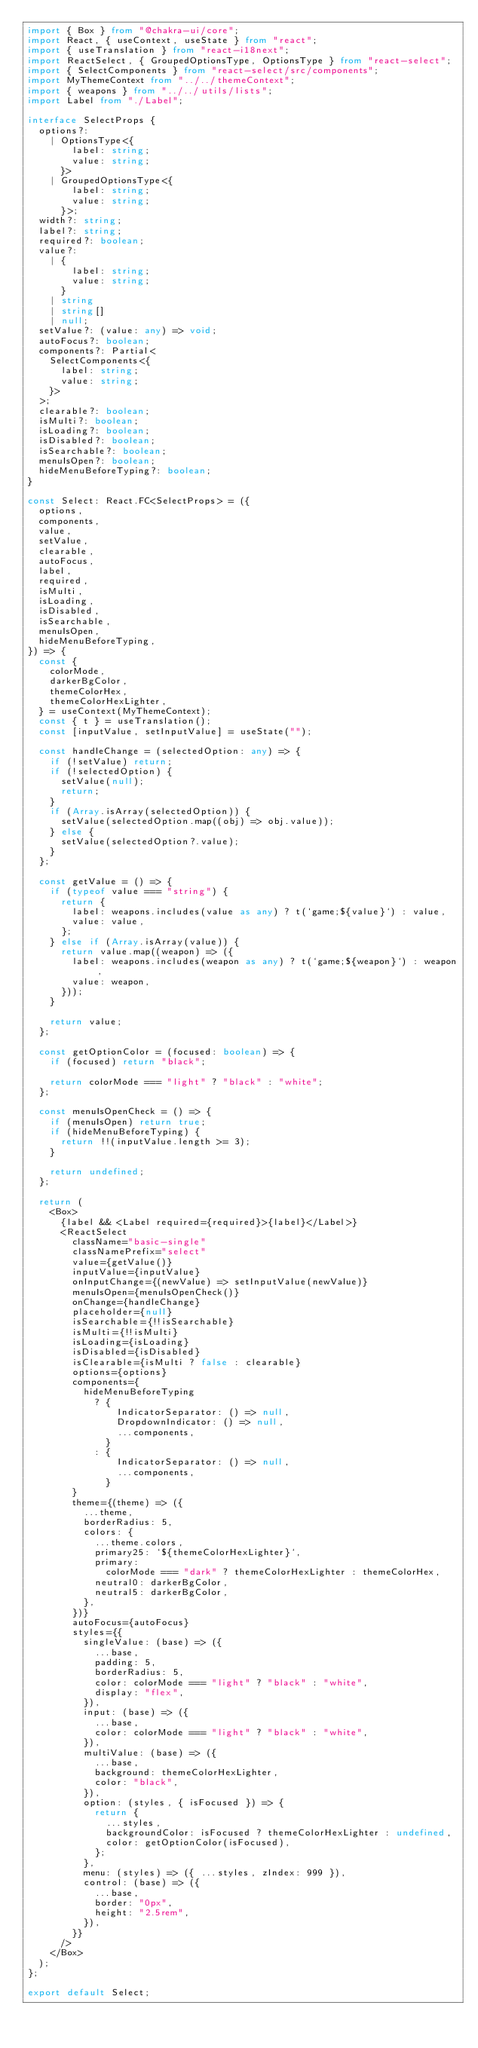<code> <loc_0><loc_0><loc_500><loc_500><_TypeScript_>import { Box } from "@chakra-ui/core";
import React, { useContext, useState } from "react";
import { useTranslation } from "react-i18next";
import ReactSelect, { GroupedOptionsType, OptionsType } from "react-select";
import { SelectComponents } from "react-select/src/components";
import MyThemeContext from "../../themeContext";
import { weapons } from "../../utils/lists";
import Label from "./Label";

interface SelectProps {
  options?:
    | OptionsType<{
        label: string;
        value: string;
      }>
    | GroupedOptionsType<{
        label: string;
        value: string;
      }>;
  width?: string;
  label?: string;
  required?: boolean;
  value?:
    | {
        label: string;
        value: string;
      }
    | string
    | string[]
    | null;
  setValue?: (value: any) => void;
  autoFocus?: boolean;
  components?: Partial<
    SelectComponents<{
      label: string;
      value: string;
    }>
  >;
  clearable?: boolean;
  isMulti?: boolean;
  isLoading?: boolean;
  isDisabled?: boolean;
  isSearchable?: boolean;
  menuIsOpen?: boolean;
  hideMenuBeforeTyping?: boolean;
}

const Select: React.FC<SelectProps> = ({
  options,
  components,
  value,
  setValue,
  clearable,
  autoFocus,
  label,
  required,
  isMulti,
  isLoading,
  isDisabled,
  isSearchable,
  menuIsOpen,
  hideMenuBeforeTyping,
}) => {
  const {
    colorMode,
    darkerBgColor,
    themeColorHex,
    themeColorHexLighter,
  } = useContext(MyThemeContext);
  const { t } = useTranslation();
  const [inputValue, setInputValue] = useState("");

  const handleChange = (selectedOption: any) => {
    if (!setValue) return;
    if (!selectedOption) {
      setValue(null);
      return;
    }
    if (Array.isArray(selectedOption)) {
      setValue(selectedOption.map((obj) => obj.value));
    } else {
      setValue(selectedOption?.value);
    }
  };

  const getValue = () => {
    if (typeof value === "string") {
      return {
        label: weapons.includes(value as any) ? t(`game;${value}`) : value,
        value: value,
      };
    } else if (Array.isArray(value)) {
      return value.map((weapon) => ({
        label: weapons.includes(weapon as any) ? t(`game;${weapon}`) : weapon,
        value: weapon,
      }));
    }

    return value;
  };

  const getOptionColor = (focused: boolean) => {
    if (focused) return "black";

    return colorMode === "light" ? "black" : "white";
  };

  const menuIsOpenCheck = () => {
    if (menuIsOpen) return true;
    if (hideMenuBeforeTyping) {
      return !!(inputValue.length >= 3);
    }

    return undefined;
  };

  return (
    <Box>
      {label && <Label required={required}>{label}</Label>}
      <ReactSelect
        className="basic-single"
        classNamePrefix="select"
        value={getValue()}
        inputValue={inputValue}
        onInputChange={(newValue) => setInputValue(newValue)}
        menuIsOpen={menuIsOpenCheck()}
        onChange={handleChange}
        placeholder={null}
        isSearchable={!!isSearchable}
        isMulti={!!isMulti}
        isLoading={isLoading}
        isDisabled={isDisabled}
        isClearable={isMulti ? false : clearable}
        options={options}
        components={
          hideMenuBeforeTyping
            ? {
                IndicatorSeparator: () => null,
                DropdownIndicator: () => null,
                ...components,
              }
            : {
                IndicatorSeparator: () => null,
                ...components,
              }
        }
        theme={(theme) => ({
          ...theme,
          borderRadius: 5,
          colors: {
            ...theme.colors,
            primary25: `${themeColorHexLighter}`,
            primary:
              colorMode === "dark" ? themeColorHexLighter : themeColorHex,
            neutral0: darkerBgColor,
            neutral5: darkerBgColor,
          },
        })}
        autoFocus={autoFocus}
        styles={{
          singleValue: (base) => ({
            ...base,
            padding: 5,
            borderRadius: 5,
            color: colorMode === "light" ? "black" : "white",
            display: "flex",
          }),
          input: (base) => ({
            ...base,
            color: colorMode === "light" ? "black" : "white",
          }),
          multiValue: (base) => ({
            ...base,
            background: themeColorHexLighter,
            color: "black",
          }),
          option: (styles, { isFocused }) => {
            return {
              ...styles,
              backgroundColor: isFocused ? themeColorHexLighter : undefined,
              color: getOptionColor(isFocused),
            };
          },
          menu: (styles) => ({ ...styles, zIndex: 999 }),
          control: (base) => ({
            ...base,
            border: "0px",
            height: "2.5rem",
          }),
        }}
      />
    </Box>
  );
};

export default Select;
</code> 